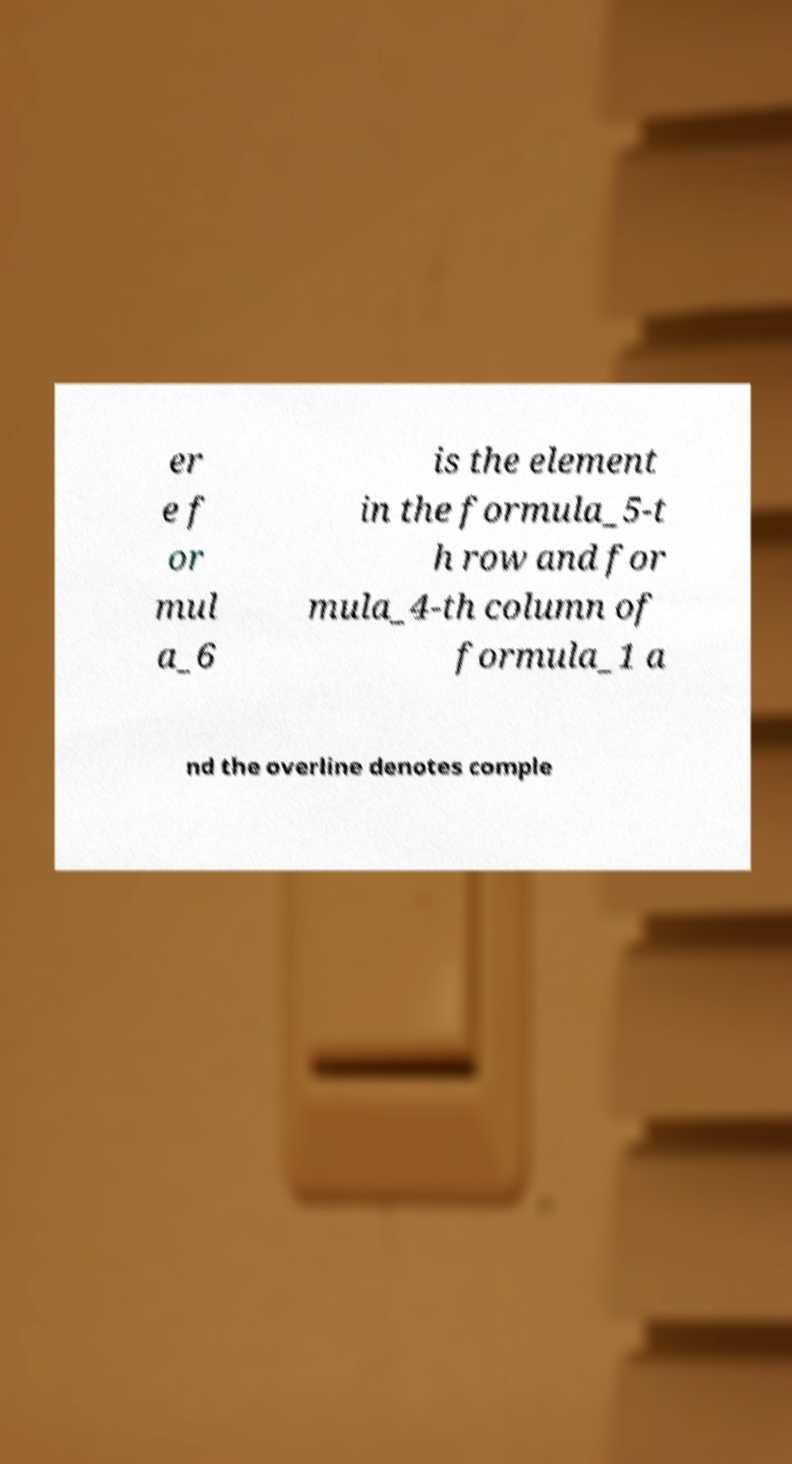Could you extract and type out the text from this image? er e f or mul a_6 is the element in the formula_5-t h row and for mula_4-th column of formula_1 a nd the overline denotes comple 